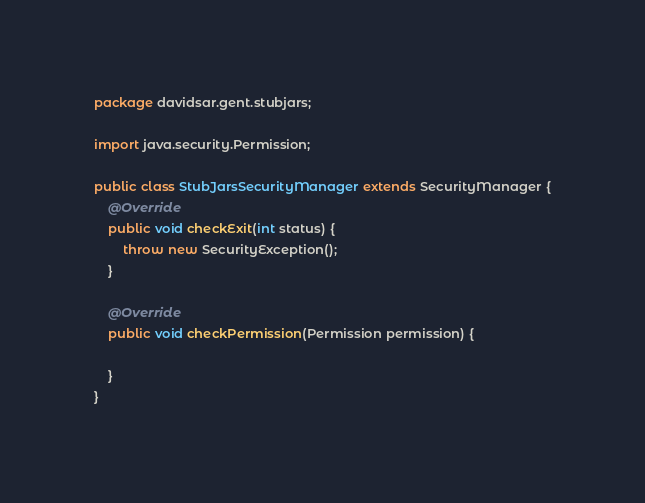<code> <loc_0><loc_0><loc_500><loc_500><_Java_>package davidsar.gent.stubjars;

import java.security.Permission;

public class StubJarsSecurityManager extends SecurityManager {
    @Override
    public void checkExit(int status) {
        throw new SecurityException();
    }

    @Override
    public void checkPermission(Permission permission) {

    }
}
</code> 